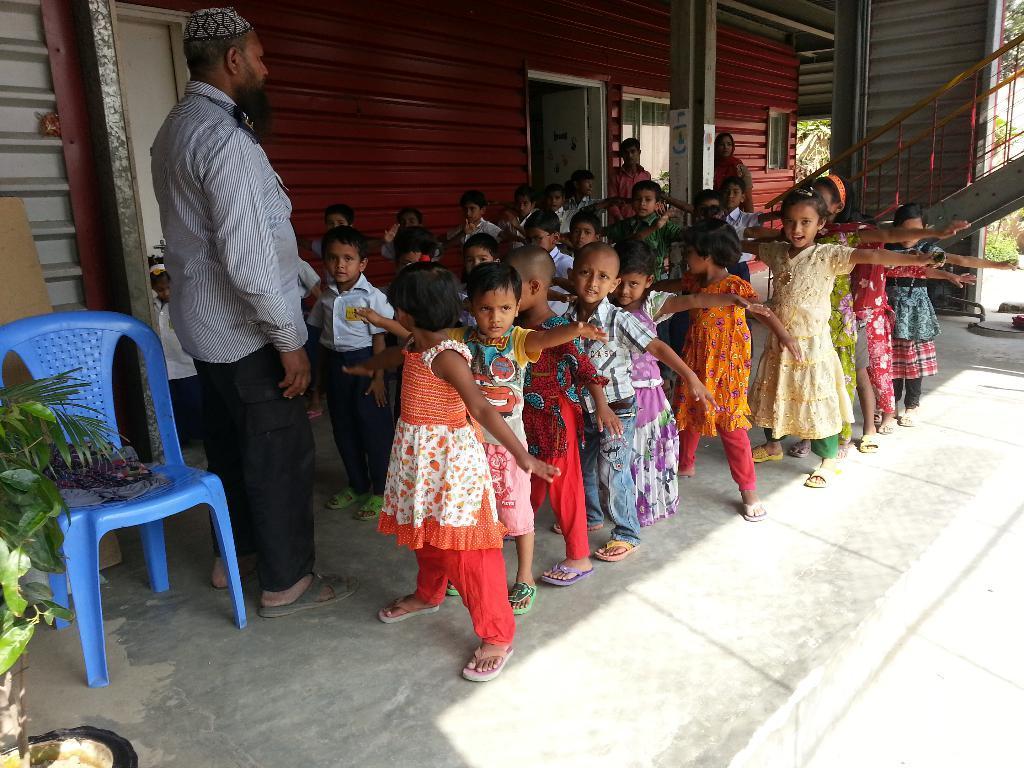Can you describe this image briefly? In this image there are few kids. In front of them a man is standing. Behind him there is blue chair. In the background there are building, door, window, staircase, trees. In the left there is a plant pot. 